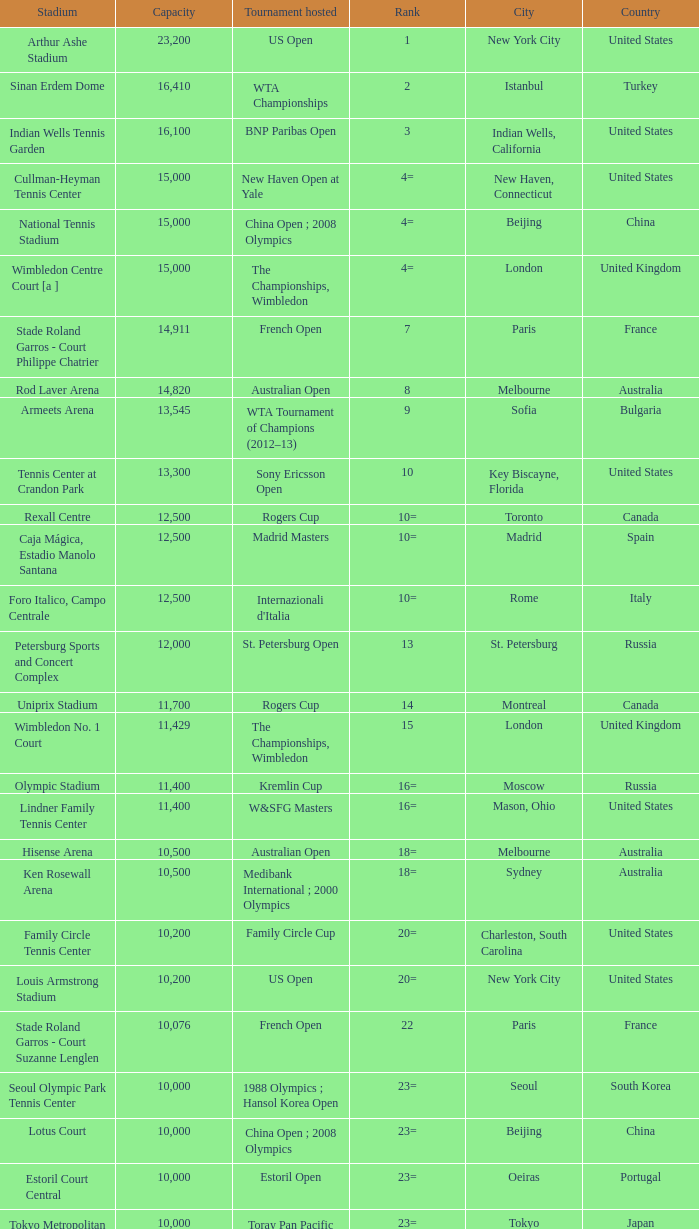What country has grandstand stadium as the stadium? United States. 